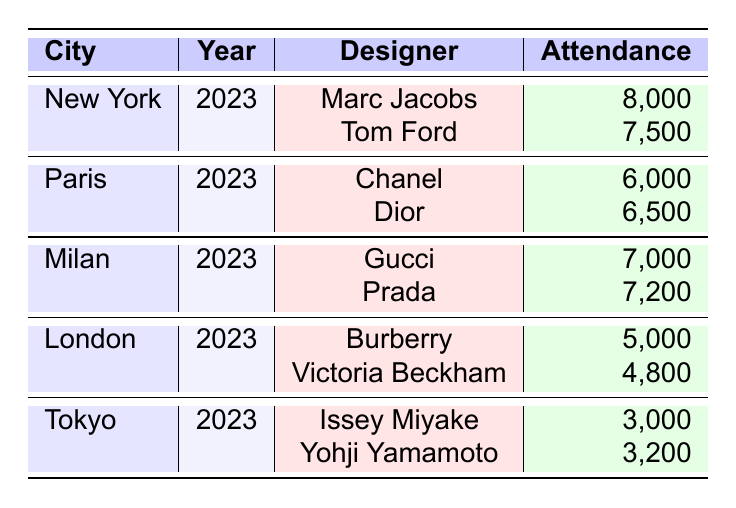What is the total attendance for New York Fashion Week in 2023? Adding the attendance of both designers in New York: 8,000 (Marc Jacobs) + 7,500 (Tom Ford) = 15,500
Answer: 15,500 Which designer had the highest attendance at Paris Fashion Week in 2023? Comparing the attendance numbers for Chanel (6,000) and Dior (6,500), Dior has the higher attendance.
Answer: Dior What was the average attendance of all designers at Milan Fashion Week in 2023? Adding Gucci's and Prada's attendance: 7,000 + 7,200 = 14,200; there are 2 designers, so the average is 14,200 / 2 = 7,100.
Answer: 7,100 Did any designer at London Fashion Week 2023 have an attendance greater than 5,000? Comparing the attendances: Burberry (5,000) and Victoria Beckham (4,800), neither designer exceeded 5,000.
Answer: No What is the attendance difference between the highest and lowest attended designer in Tokyo Fashion Week? Issey Miyake had 3,000 attendees and Yohji Yamamoto had 3,200; the difference is 3,200 - 3,000 = 200.
Answer: 200 Which city had the lowest total attendance across all designers for Fashion Week 2023? Calculating total attendance for each city: New York = 15,500, Paris = 12,500, Milan = 14,200, London = 9,800, Tokyo = 6,200. London has the lowest total attendance.
Answer: London How many designers participated in Paris Fashion Week 2023? There are two designers listed for Paris: Chanel and Dior. Thus, 2 designers participated.
Answer: 2 What was the combined attendance for all designers in 2023 across all cities? Adding all attendance values: 8,000 + 7,500 + 6,000 + 6,500 + 7,000 + 7,200 + 5,000 + 4,800 + 3,000 + 3,200 = 53,200.
Answer: 53,200 Which city had a higher average attendance, Milan or Tokyo? Sum of Milan's attendance: 7,000 + 7,200 = 14,200; average = 14,200 / 2 = 7,100; Tokyo's attendance: 3,000 + 3,200 = 6,200; average = 6,200 / 2 = 3,100. Milan has the higher average attendance.
Answer: Milan Is it true that all designers in New York had attendance above 7,000? Marc Jacobs had 8,000, but Tom Ford had only 7,500, which is not above 7,000.
Answer: No 